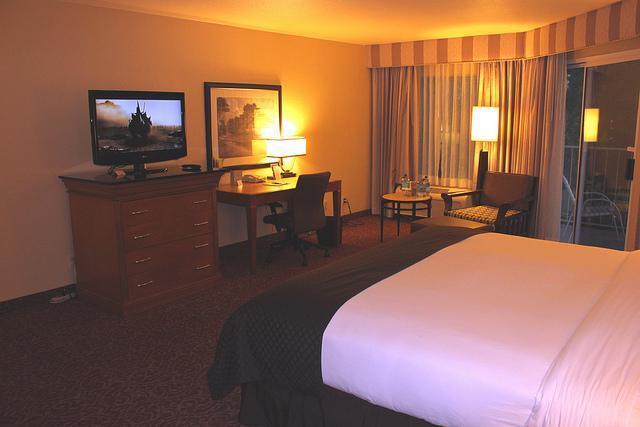How many lamps is there?
Give a very brief answer. 2. How many chairs can be seen?
Give a very brief answer. 2. How many people are walking under the umbrella?
Give a very brief answer. 0. 